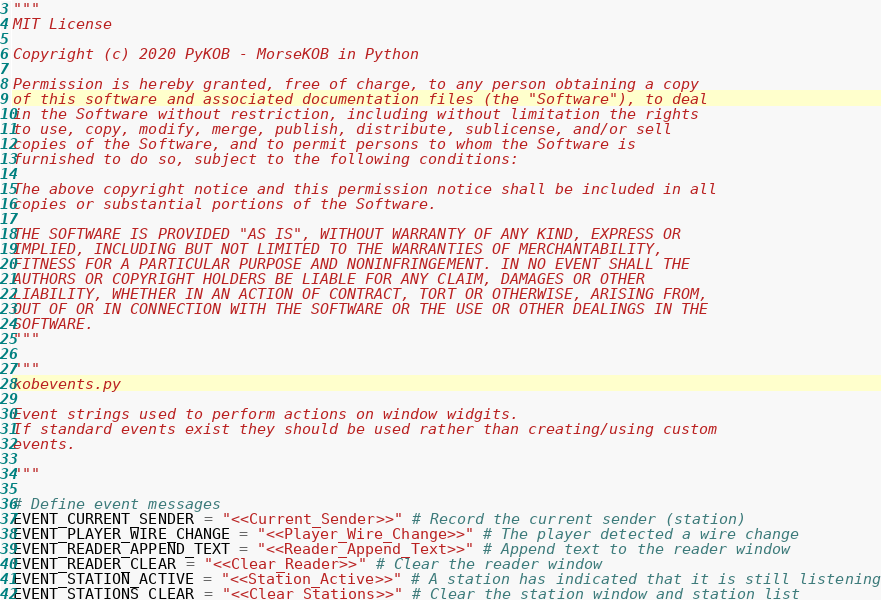<code> <loc_0><loc_0><loc_500><loc_500><_Python_>"""
MIT License

Copyright (c) 2020 PyKOB - MorseKOB in Python

Permission is hereby granted, free of charge, to any person obtaining a copy
of this software and associated documentation files (the "Software"), to deal
in the Software without restriction, including without limitation the rights
to use, copy, modify, merge, publish, distribute, sublicense, and/or sell
copies of the Software, and to permit persons to whom the Software is
furnished to do so, subject to the following conditions:

The above copyright notice and this permission notice shall be included in all
copies or substantial portions of the Software.

THE SOFTWARE IS PROVIDED "AS IS", WITHOUT WARRANTY OF ANY KIND, EXPRESS OR
IMPLIED, INCLUDING BUT NOT LIMITED TO THE WARRANTIES OF MERCHANTABILITY,
FITNESS FOR A PARTICULAR PURPOSE AND NONINFRINGEMENT. IN NO EVENT SHALL THE
AUTHORS OR COPYRIGHT HOLDERS BE LIABLE FOR ANY CLAIM, DAMAGES OR OTHER
LIABILITY, WHETHER IN AN ACTION OF CONTRACT, TORT OR OTHERWISE, ARISING FROM,
OUT OF OR IN CONNECTION WITH THE SOFTWARE OR THE USE OR OTHER DEALINGS IN THE
SOFTWARE.
"""

"""
kobevents.py

Event strings used to perform actions on window widgits.
If standard events exist they should be used rather than creating/using custom 
events.

"""

# Define event messages
EVENT_CURRENT_SENDER = "<<Current_Sender>>" # Record the current sender (station)
EVENT_PLAYER_WIRE_CHANGE = "<<Player_Wire_Change>>" # The player detected a wire change
EVENT_READER_APPEND_TEXT = "<<Reader_Append_Text>>" # Append text to the reader window
EVENT_READER_CLEAR = "<<Clear_Reader>>" # Clear the reader window
EVENT_STATION_ACTIVE = "<<Station_Active>>" # A station has indicated that it is still listening
EVENT_STATIONS_CLEAR = "<<Clear_Stations>>" # Clear the station window and station list
</code> 